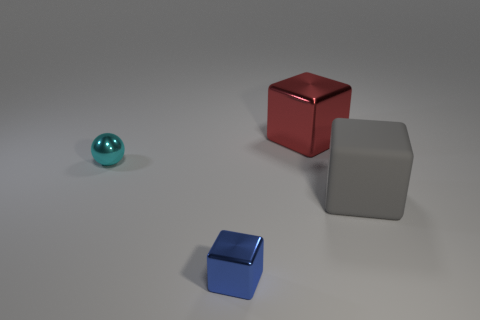The other thing that is the same size as the gray thing is what shape?
Offer a terse response. Cube. What number of rubber things are tiny blocks or brown spheres?
Your response must be concise. 0. Is the block in front of the large gray cube made of the same material as the object that is on the left side of the blue shiny cube?
Keep it short and to the point. Yes. What color is the small thing that is the same material as the tiny ball?
Give a very brief answer. Blue. Are there more cyan balls that are behind the big metal thing than tiny cyan things on the right side of the tiny cube?
Ensure brevity in your answer.  No. Is there a brown metal ball?
Provide a short and direct response. No. How many things are small green rubber blocks or tiny objects?
Offer a very short reply. 2. Are there any other small metallic spheres of the same color as the metal sphere?
Make the answer very short. No. There is a big object behind the large rubber object; how many red shiny things are in front of it?
Ensure brevity in your answer.  0. Are there more blocks than big yellow balls?
Provide a succinct answer. Yes. 